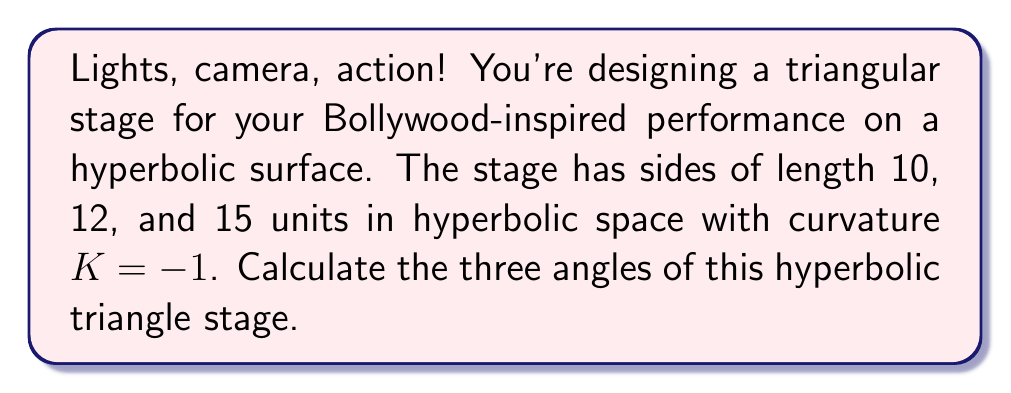Teach me how to tackle this problem. Let's approach this step-by-step using the hyperbolic law of cosines:

1) In hyperbolic geometry with curvature $K = -1$, the law of cosines states:
   $$\cosh c = \cosh a \cosh b - \sinh a \sinh b \cos C$$

2) We have three sides: $a = 10$, $b = 12$, and $c = 15$. Let's call the angles opposite to these sides A, B, and C respectively.

3) To find angle C, we use:
   $$\cosh 15 = \cosh 10 \cosh 12 - \sinh 10 \sinh 12 \cos C$$

4) Calculate the hyperbolic functions:
   $$\cosh 15 \approx 1,634,508.6864$$
   $$\cosh 10 \approx 11,013.2329$$
   $$\cosh 12 \approx 81,377.3957$$
   $$\sinh 10 \approx 11,013.2329$$
   $$\sinh 12 \approx 81,377.3956$$

5) Substitute these values:
   $$1,634,508.6864 = (11,013.2329)(81,377.3957) - (11,013.2329)(81,377.3956)\cos C$$

6) Solve for $\cos C$:
   $$\cos C \approx 0.9997$$

7) Therefore, $C = \arccos(0.9997) \approx 0.0245$ radians or $1.4043°$

8) Repeat steps 3-7 for angles A and B:
   For A: $\cosh 12 = \cosh 15 \cosh 10 - \sinh 15 \sinh 10 \cos A$
   For B: $\cosh 10 = \cosh 15 \cosh 12 - \sinh 15 \sinh 12 \cos B$

9) Solving these equations:
   $A \approx 0.0817$ radians or $4.6837°$
   $B \approx 0.0656$ radians or $3.7589°$

10) Check: In hyperbolic geometry, the sum of angles in a triangle is less than 180°.
    $1.4043° + 4.6837° + 3.7589° = 9.8469° < 180°$, which is correct.
Answer: $A \approx 4.6837°$, $B \approx 3.7589°$, $C \approx 1.4043°$ 